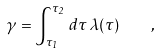Convert formula to latex. <formula><loc_0><loc_0><loc_500><loc_500>\gamma = \int _ { \tau _ { 1 } } ^ { \tau _ { 2 } } \, d \tau \, \lambda ( \tau ) \quad ,</formula> 